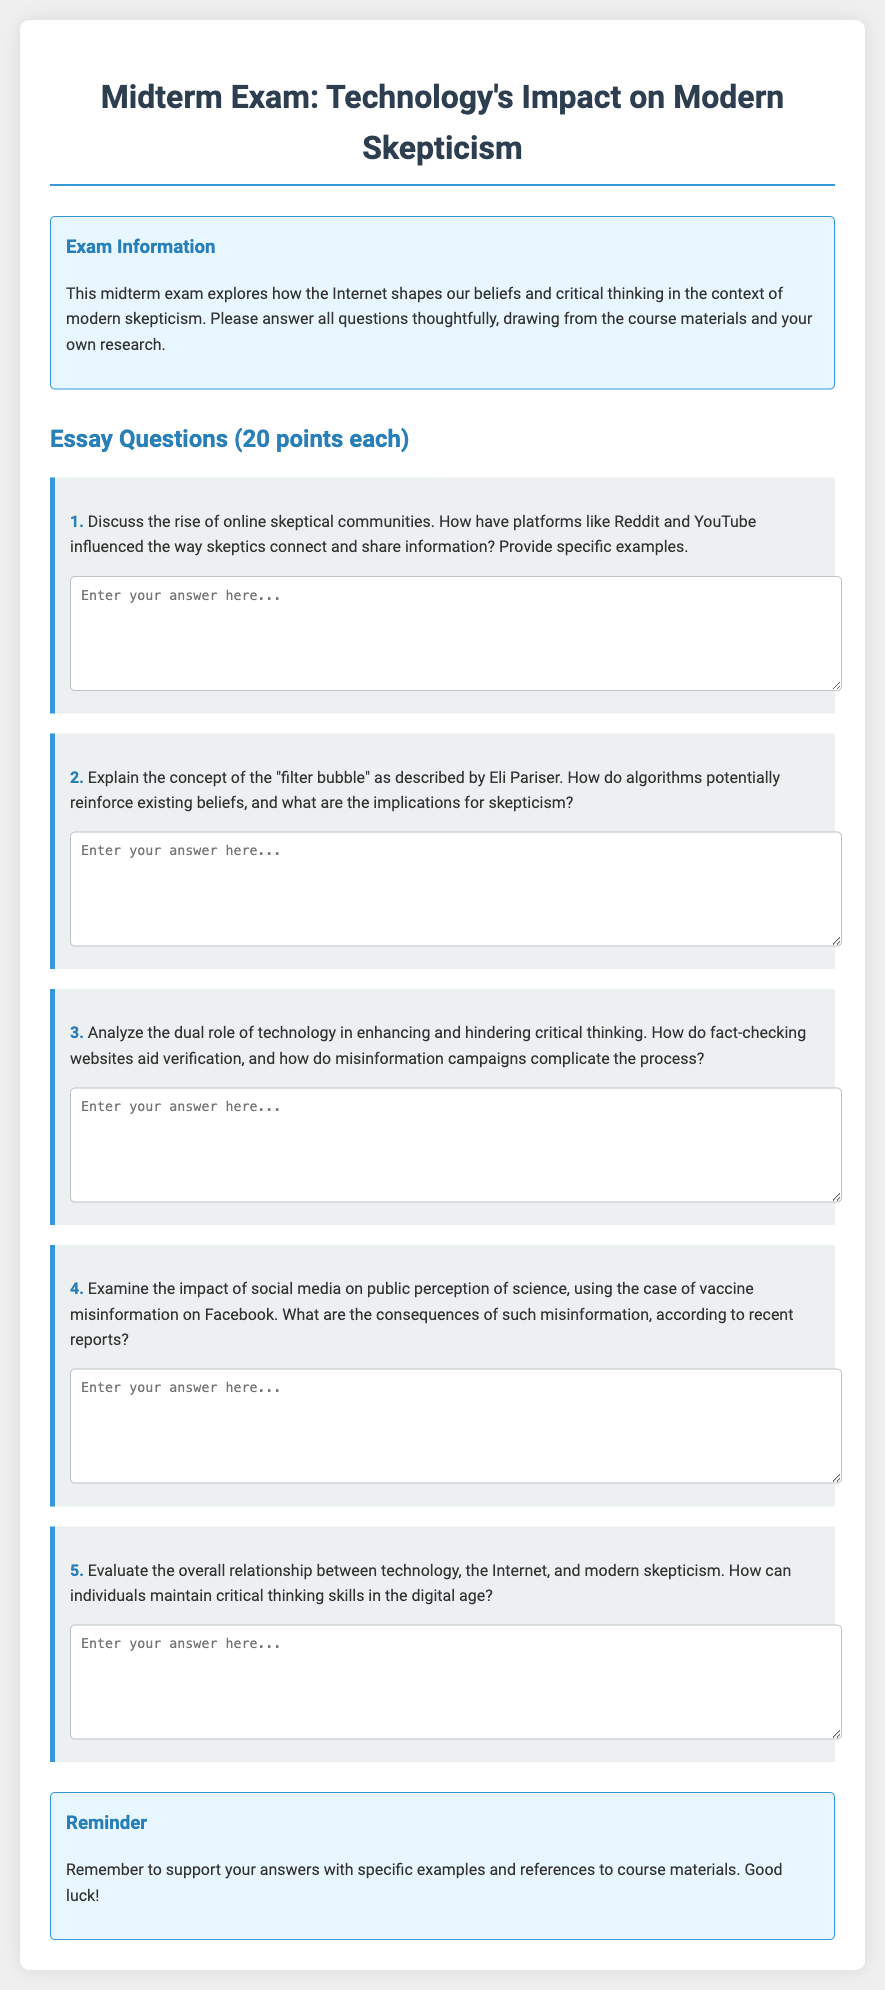What is the title of the exam? The title of the exam is provided at the top of the document.
Answer: Technology's Impact on Modern Skepticism How many essay questions are in the exam? The document explicitly states the number of essay questions included.
Answer: Five What is the point value for each essay question? The points assigned to each question can be found in the exam instructions.
Answer: 20 points Who is mentioned in the document as having described the "filter bubble"? A specific individual's name is mentioned in relation to the "filter bubble" concept.
Answer: Eli Pariser What online platforms are mentioned as influential for skeptical communities? The document provides examples of platforms relevant to the discussion of skeptical communities.
Answer: Reddit and YouTube What type of misinformation case is analyzed in the fourth question? The fourth question focuses on a specific instance of misinformation in the context of public perception.
Answer: Vaccine misinformation What is suggested for individuals to maintain in the digital age? The document advises on a skill for individuals navigating technology and skepticism.
Answer: Critical thinking skills What type of box contains the exam information? The document uses a specific visual structure to present important information about the exam.
Answer: Info box What is the background color of the body in the document? The background color is specified in the document's style settings.
Answer: Light gray 